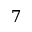<formula> <loc_0><loc_0><loc_500><loc_500>7</formula> 